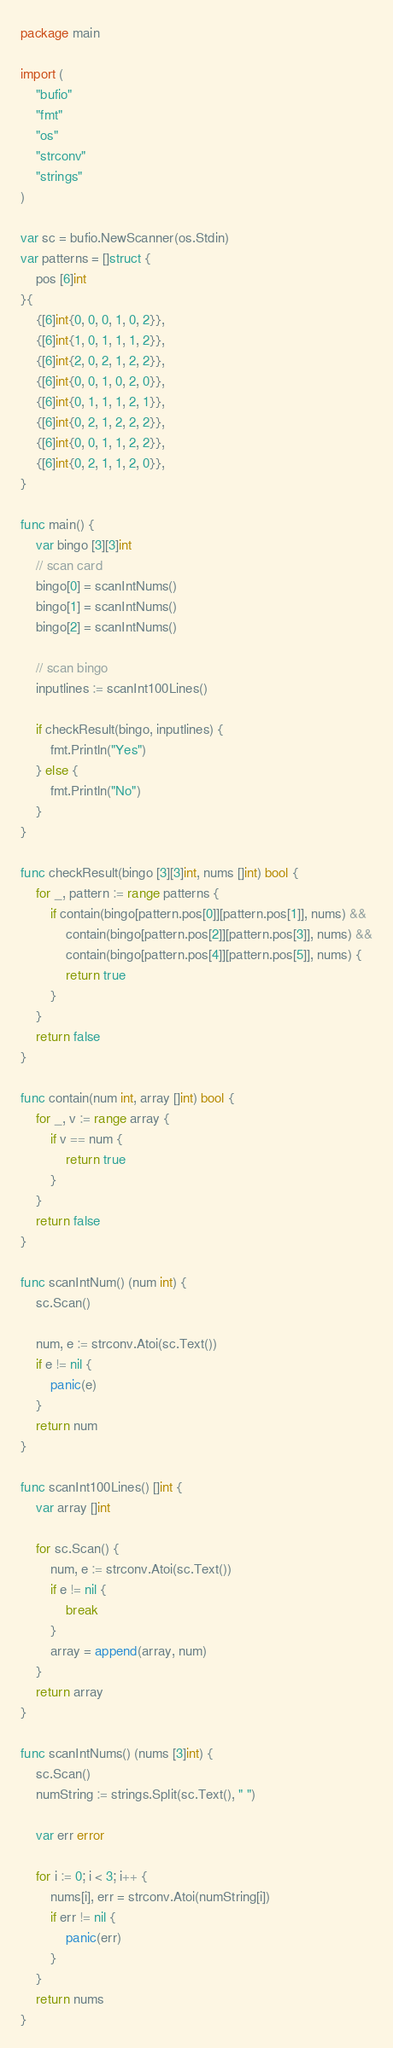<code> <loc_0><loc_0><loc_500><loc_500><_Go_>package main

import (
	"bufio"
	"fmt"
	"os"
	"strconv"
	"strings"
)

var sc = bufio.NewScanner(os.Stdin)
var patterns = []struct {
	pos [6]int
}{
	{[6]int{0, 0, 0, 1, 0, 2}},
	{[6]int{1, 0, 1, 1, 1, 2}},
	{[6]int{2, 0, 2, 1, 2, 2}},
	{[6]int{0, 0, 1, 0, 2, 0}},
	{[6]int{0, 1, 1, 1, 2, 1}},
	{[6]int{0, 2, 1, 2, 2, 2}},
	{[6]int{0, 0, 1, 1, 2, 2}},
	{[6]int{0, 2, 1, 1, 2, 0}},
}

func main() {
	var bingo [3][3]int
	// scan card
	bingo[0] = scanIntNums()
	bingo[1] = scanIntNums()
	bingo[2] = scanIntNums()

	// scan bingo
	inputlines := scanInt100Lines()

	if checkResult(bingo, inputlines) {
		fmt.Println("Yes")
	} else {
		fmt.Println("No")
	}
}

func checkResult(bingo [3][3]int, nums []int) bool {
	for _, pattern := range patterns {
		if contain(bingo[pattern.pos[0]][pattern.pos[1]], nums) &&
			contain(bingo[pattern.pos[2]][pattern.pos[3]], nums) &&
			contain(bingo[pattern.pos[4]][pattern.pos[5]], nums) {
			return true
		}
	}
	return false
}

func contain(num int, array []int) bool {
	for _, v := range array {
		if v == num {
			return true
		}
	}
	return false
}

func scanIntNum() (num int) {
	sc.Scan()

	num, e := strconv.Atoi(sc.Text())
	if e != nil {
		panic(e)
	}
	return num
}

func scanInt100Lines() []int {
	var array []int

	for sc.Scan() {
		num, e := strconv.Atoi(sc.Text())
		if e != nil {
			break
		}
		array = append(array, num)
	}
	return array
}

func scanIntNums() (nums [3]int) {
	sc.Scan()
	numString := strings.Split(sc.Text(), " ")

	var err error

	for i := 0; i < 3; i++ {
		nums[i], err = strconv.Atoi(numString[i])
		if err != nil {
			panic(err)
		}
	}
	return nums
}
</code> 